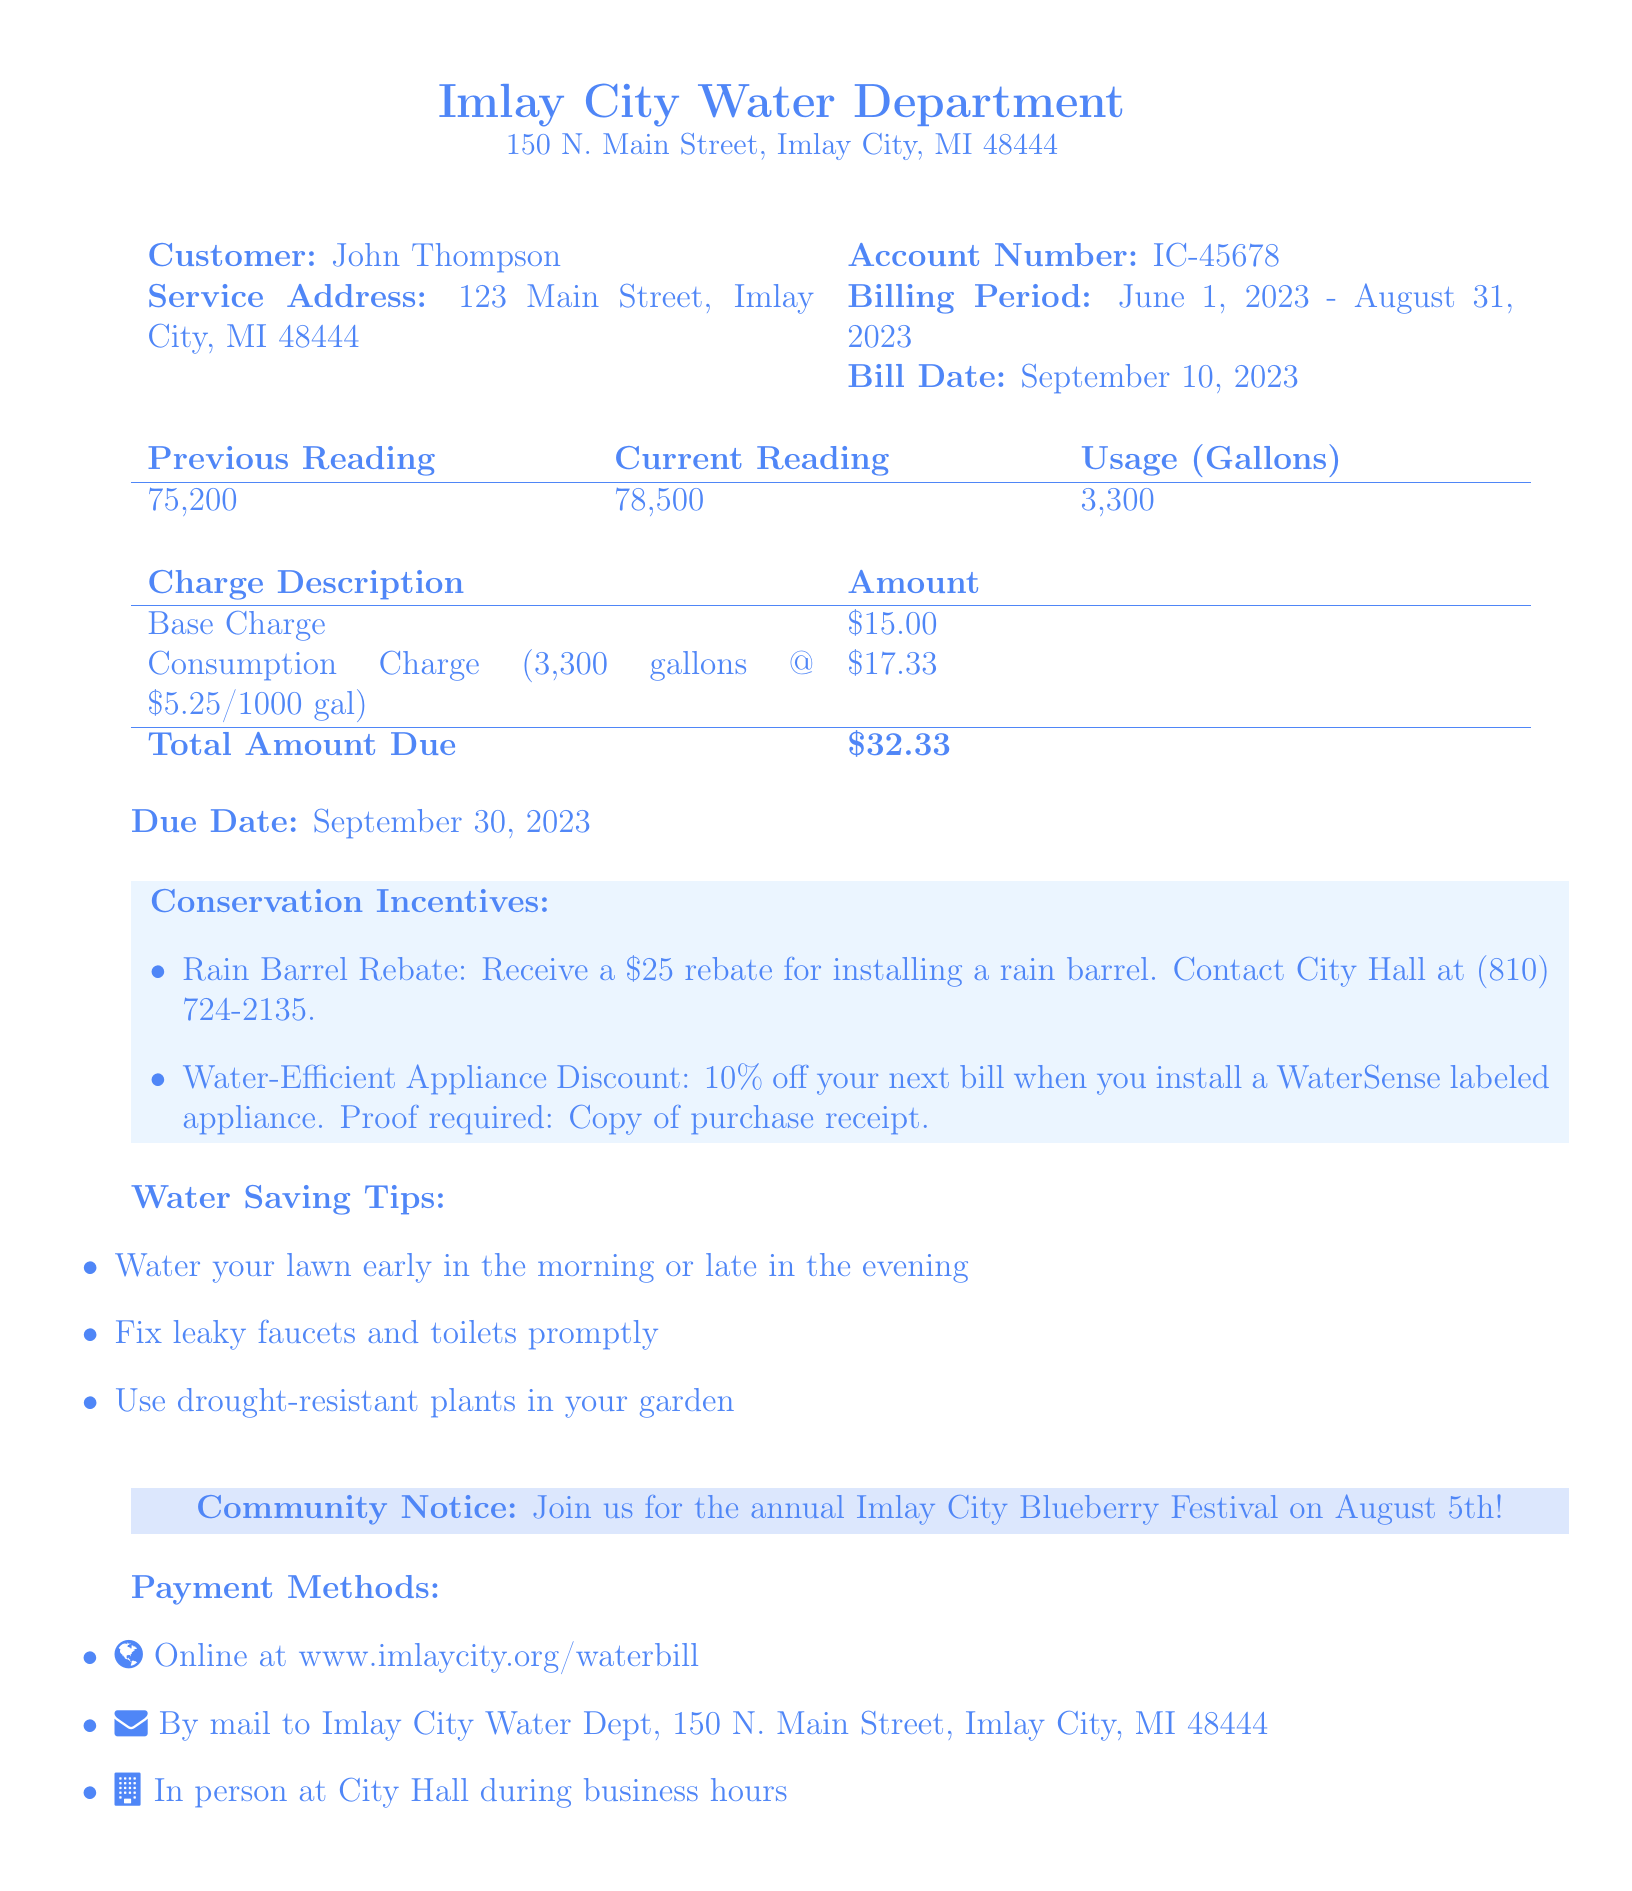What is the account number? The account number is specified in the document next to the customer information.
Answer: IC-45678 What is the total amount due? The total amount due is calculated from the charges listed in the bill.
Answer: $32.33 What is the billing period? The billing period is stated clearly in the account details section of the document.
Answer: June 1, 2023 - August 31, 2023 How many gallons of water were used? The usage is presented in the table as the difference between the current reading and the previous reading.
Answer: 3,300 What rebate is offered for rain barrels? The rebate for installing a rain barrel is detailed under conservation incentives.
Answer: $25 What percentage discount is available for WaterSense labeled appliances? This information is part of the conservation incentives in the bill.
Answer: 10% What is the due date for payment? The due date for payment is specified in the document following the total amount due.
Answer: September 30, 2023 Where can you pay online? The information regarding online payment is provided in the payment methods section.
Answer: www.imlaycity.org/waterbill When is the Imlay City Blueberry Festival? The community notice mentions the date of the event.
Answer: August 5th 